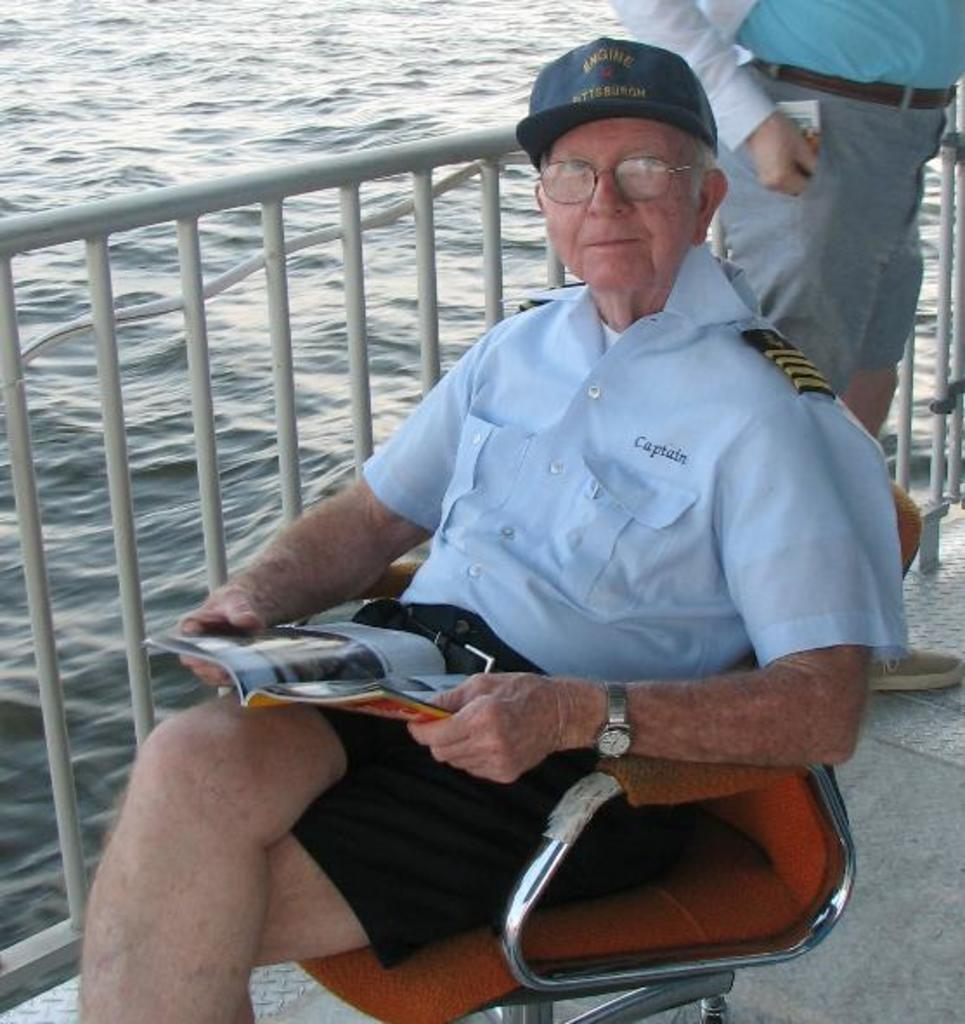What is the seated person doing in the image? The person sitting on a chair is holding a book. Can you describe the position of the standing person in the image? The standing person is beside a fence. What can be seen in the background of the image? There is water visible in the image. How many people are present in the image? There are two people in the image, one sitting and one standing. What type of needle is being used by the person sitting on the chair to create waves in the water? There is no needle or wave-creating activity present in the image. 